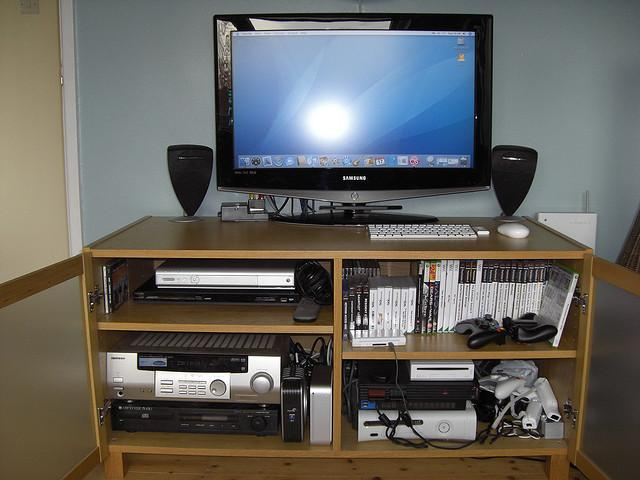What is the purpose of this setup? organization 